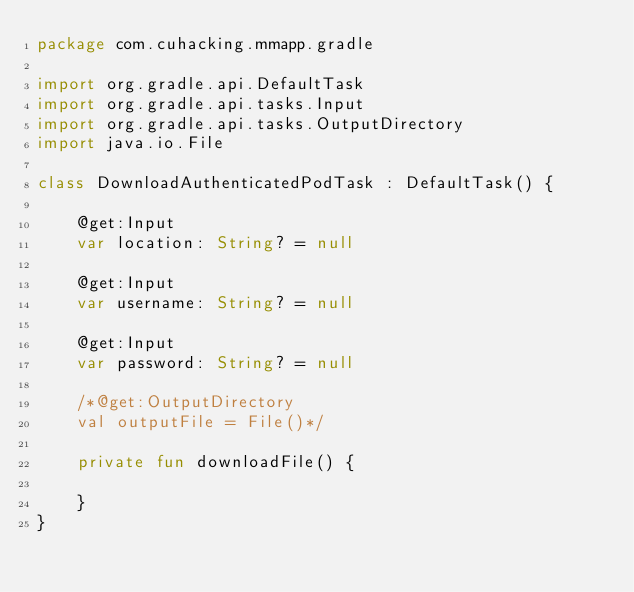<code> <loc_0><loc_0><loc_500><loc_500><_Kotlin_>package com.cuhacking.mmapp.gradle

import org.gradle.api.DefaultTask
import org.gradle.api.tasks.Input
import org.gradle.api.tasks.OutputDirectory
import java.io.File

class DownloadAuthenticatedPodTask : DefaultTask() {

    @get:Input
    var location: String? = null

    @get:Input
    var username: String? = null

    @get:Input
    var password: String? = null

    /*@get:OutputDirectory
    val outputFile = File()*/

    private fun downloadFile() {

    }
}</code> 